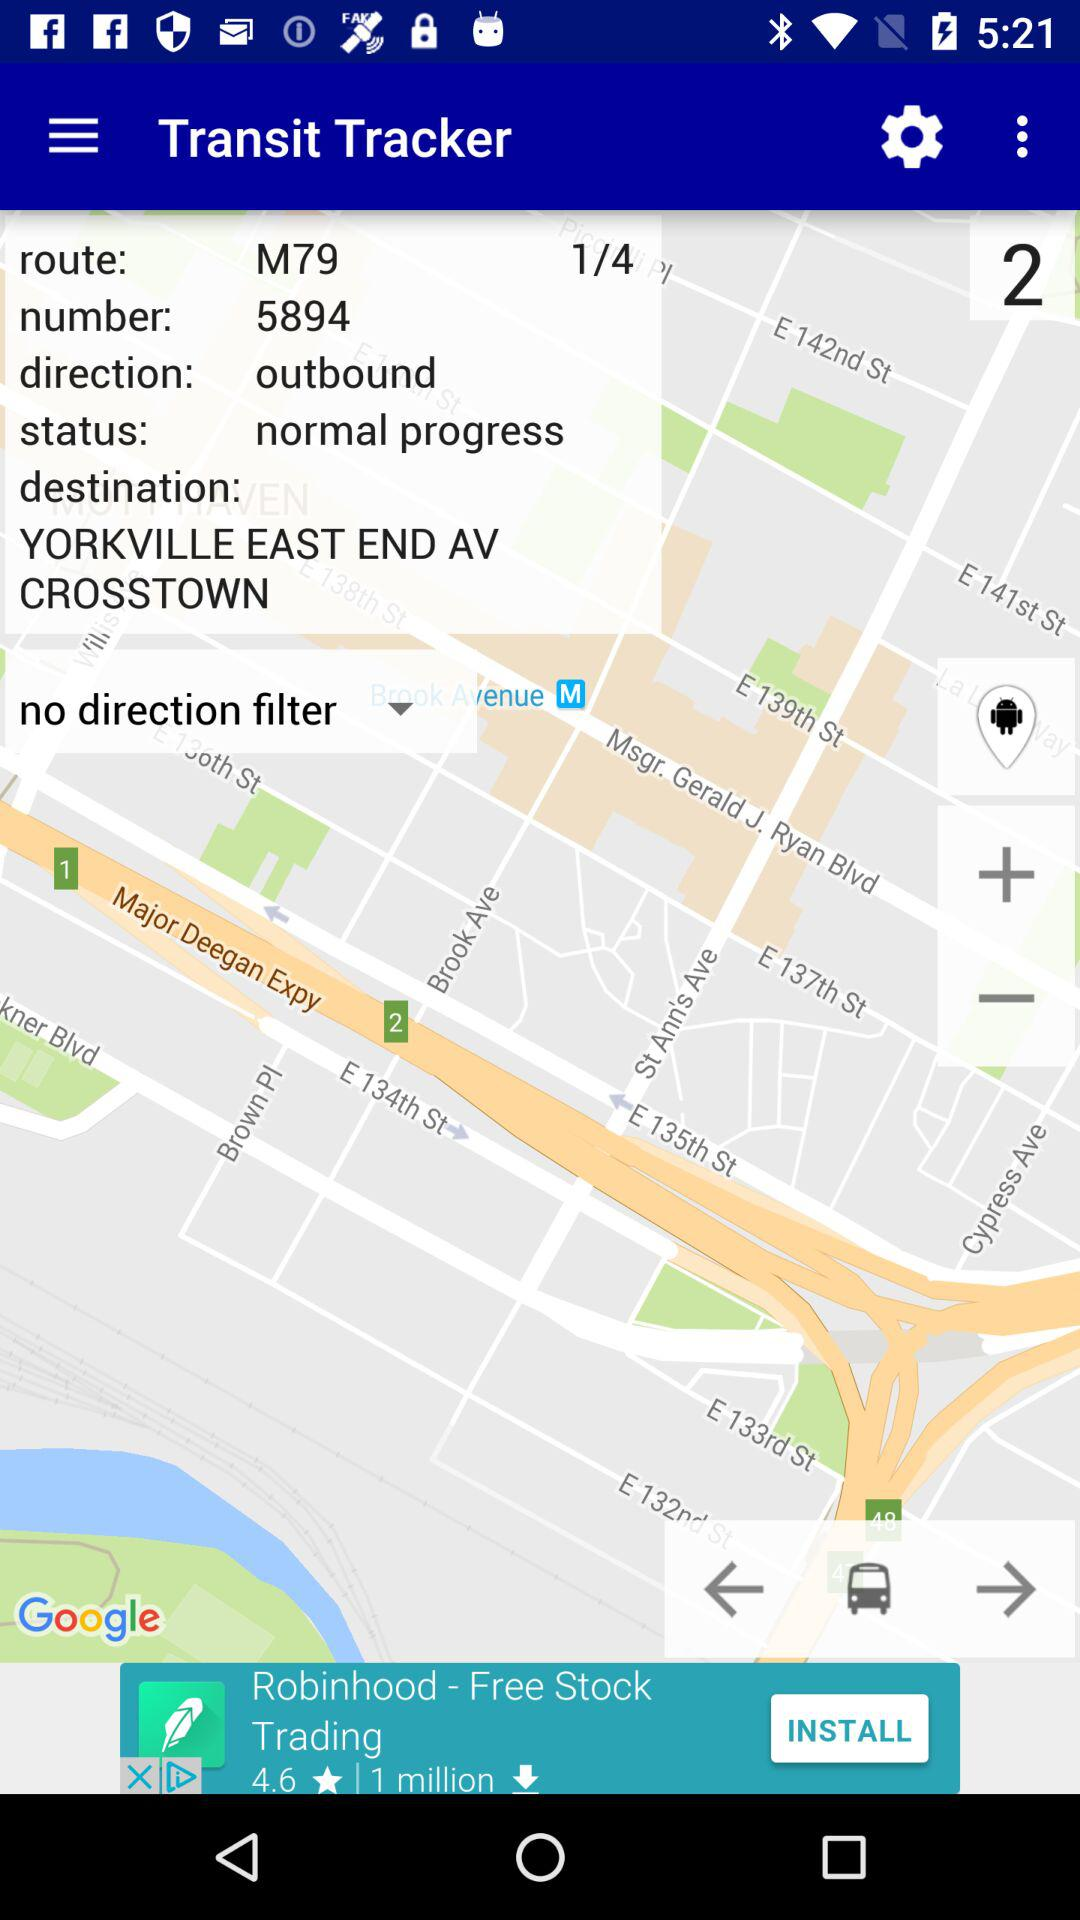What is the status of the tracker? The status of the tracker is "normal progress". 